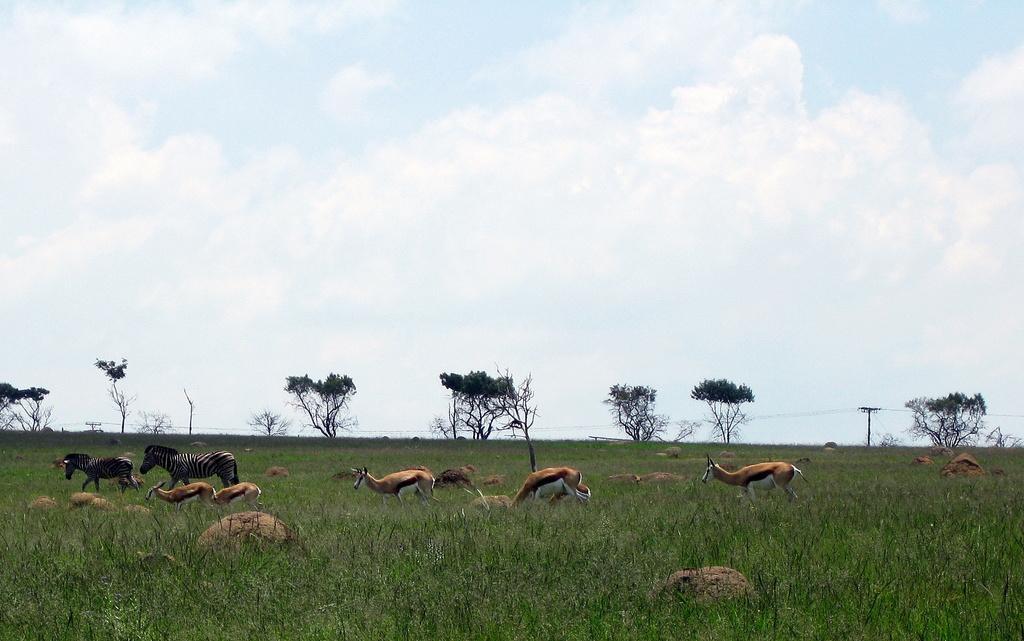Can you describe this image briefly? In this image I can see few kangaroos and they are in brown and white color. Zebras are in white and black color. Back I can see trees,pole,grass and rocks. The sky is in blue and white color. 